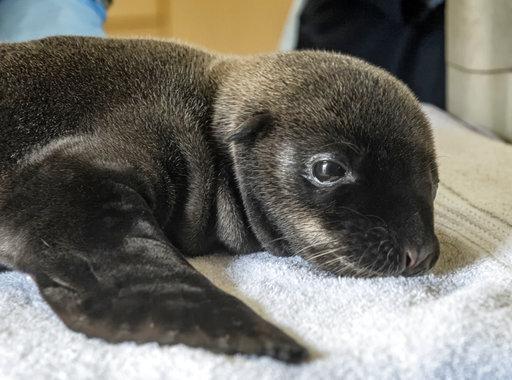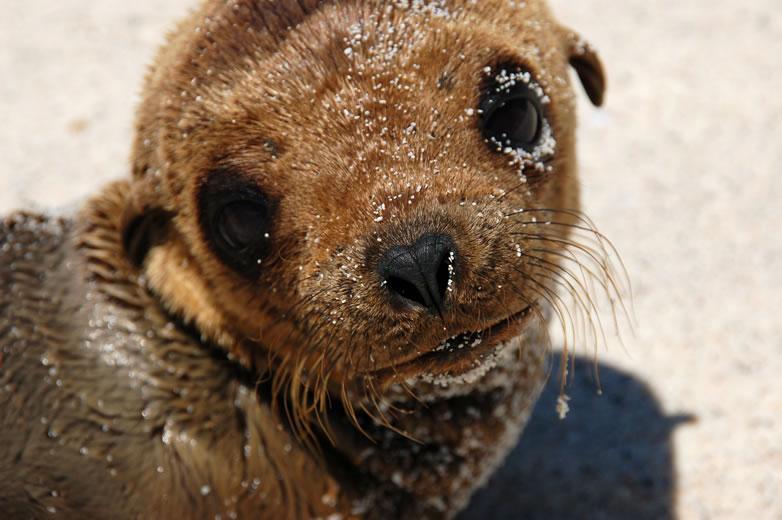The first image is the image on the left, the second image is the image on the right. Considering the images on both sides, is "At least one sea lion is facing left" valid? Answer yes or no. No. The first image is the image on the left, the second image is the image on the right. Examine the images to the left and right. Is the description "Right image features one close-mouthed brown baby seal starting into the camera." accurate? Answer yes or no. Yes. 